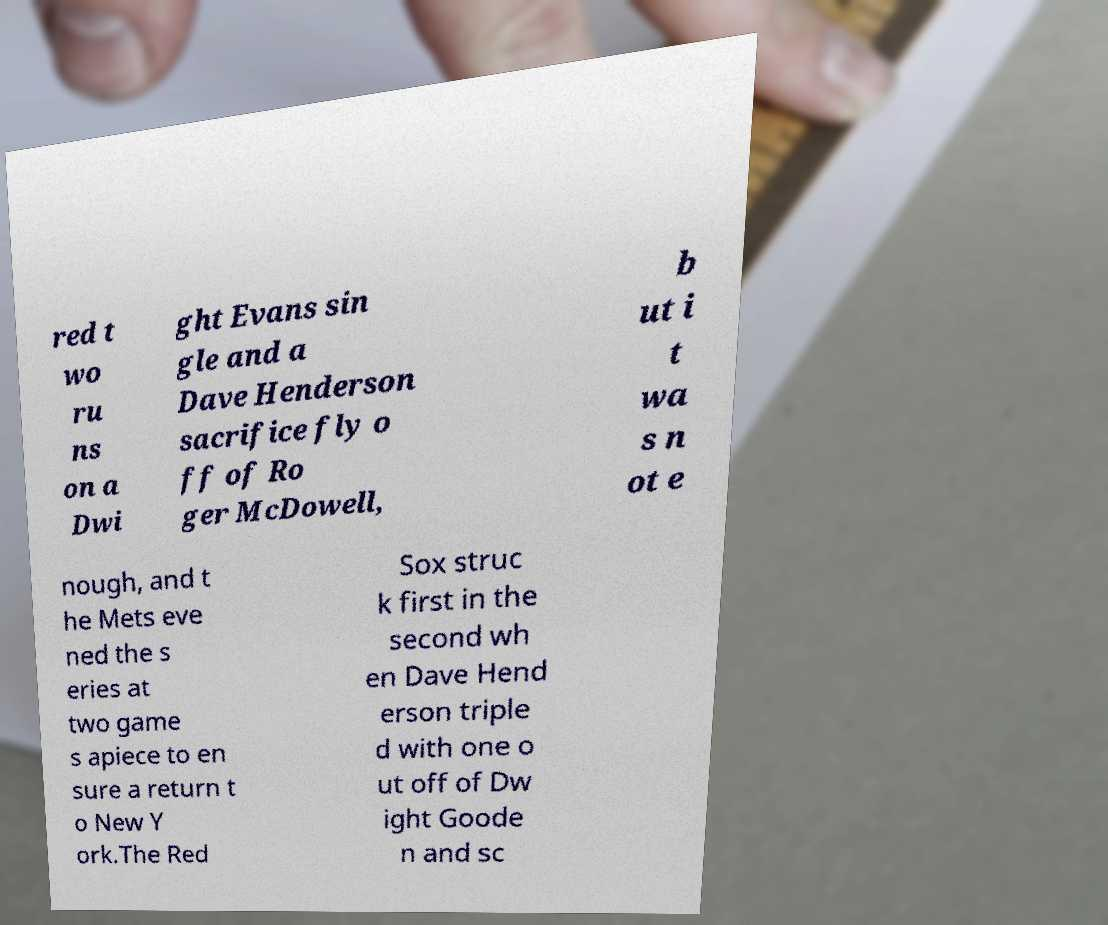I need the written content from this picture converted into text. Can you do that? red t wo ru ns on a Dwi ght Evans sin gle and a Dave Henderson sacrifice fly o ff of Ro ger McDowell, b ut i t wa s n ot e nough, and t he Mets eve ned the s eries at two game s apiece to en sure a return t o New Y ork.The Red Sox struc k first in the second wh en Dave Hend erson triple d with one o ut off of Dw ight Goode n and sc 